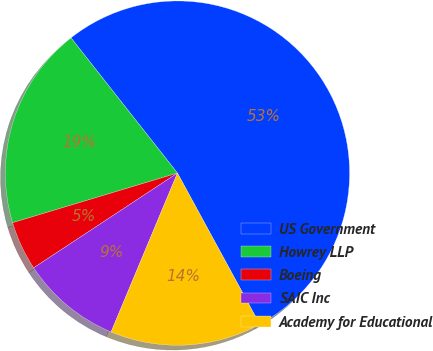Convert chart. <chart><loc_0><loc_0><loc_500><loc_500><pie_chart><fcel>US Government<fcel>Howrey LLP<fcel>Boeing<fcel>SAIC Inc<fcel>Academy for Educational<nl><fcel>52.68%<fcel>19.04%<fcel>4.62%<fcel>9.43%<fcel>14.23%<nl></chart> 